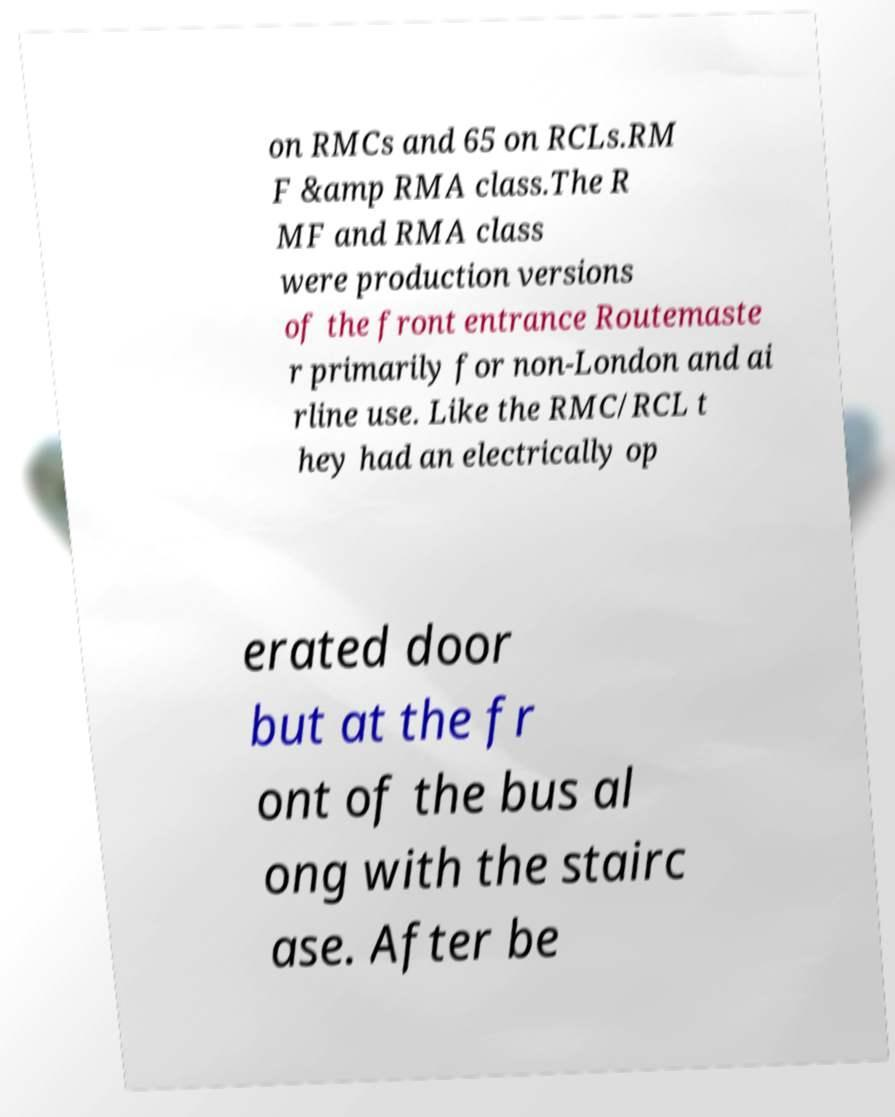For documentation purposes, I need the text within this image transcribed. Could you provide that? on RMCs and 65 on RCLs.RM F &amp RMA class.The R MF and RMA class were production versions of the front entrance Routemaste r primarily for non-London and ai rline use. Like the RMC/RCL t hey had an electrically op erated door but at the fr ont of the bus al ong with the stairc ase. After be 